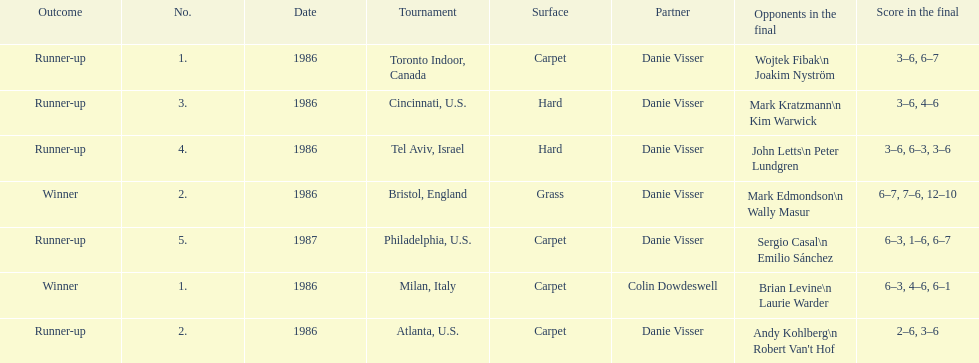Who is the last partner listed? Danie Visser. 